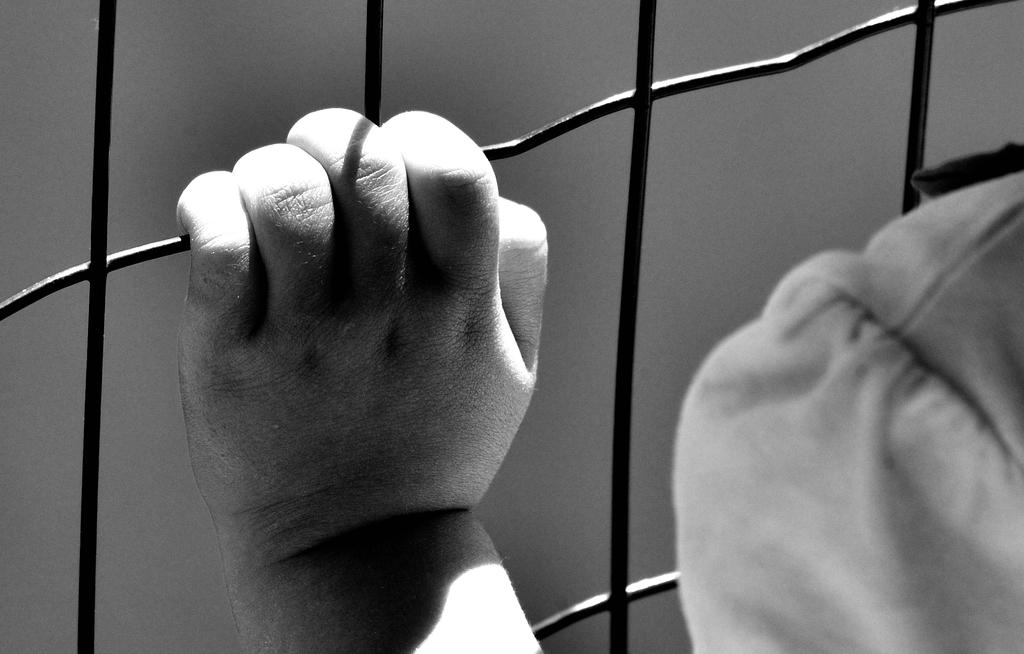What is the color scheme of the image? The image is black and white. What can be seen in the hand of the person in the image? There is a grille being held by the hand of a person in the image. How would you describe the background of the image? The background of the image is blurry. What type of distribution can be seen in the image? There is no distribution present in the image. --- Facts: 1. There is a person in the image. 2. The person is wearing a hat. 3. The person is holding a book. 4. The background of the image is a library. Absurd Topics: elephant, piano, ocean Conversation: Who or what is the main subject in the image? The main subject in the image is a person. What is the person wearing in the image? The person is wearing a hat in the image. What is the person holding in the image? The person is holding a book in the image. What can be inferred about the location of the person in the image? The person might be in a library, considering the background of the image. Reasoning: Let's think step by step in order to produce the conversation. We start by identifying the main subject of the image, which is a person. Then, we describe specific details about the person, such as the hat and the book they are holding. Finally, we infer the location of the person based on the background of the image. Absurd Question/Answer: What type of elephant can be seen playing the piano in the image? There is no elephant, piano, or ocean present in the image. 